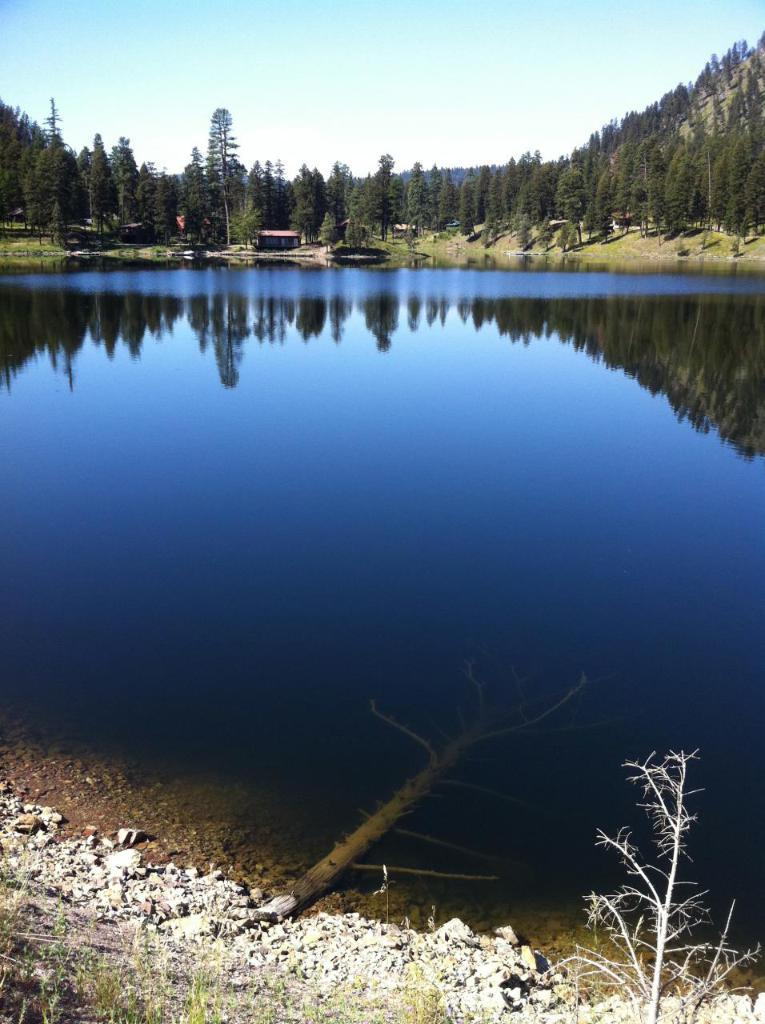What type of vegetation can be seen in the image? There is grass and plants visible in the image. What body of water can be seen in the image? There is water visible in the image. What type of dwelling is present in the image? There is a houseboat in the image. What other natural features can be seen in the image? There are trees and mountains visible in the image. What part of the natural environment is visible in the image? The sky is visible in the image. What might be the location of the image based on the visible features? The image may have been taken near a lake, given the presence of water and the houseboat. What type of weather can be seen in the image? The image does not depict any weather conditions; it only shows the natural environment and the houseboat. What type of test is being conducted in the image? There is no test being conducted in the image; it is a scene of natural surroundings and a houseboat. 